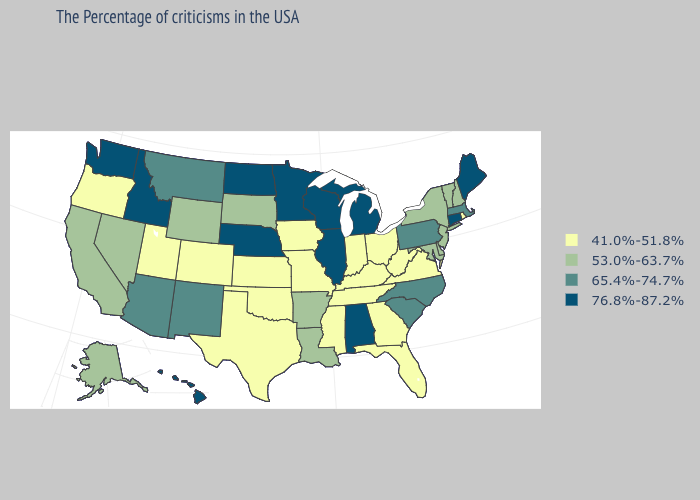What is the value of Nebraska?
Write a very short answer. 76.8%-87.2%. Name the states that have a value in the range 53.0%-63.7%?
Short answer required. New Hampshire, Vermont, New York, New Jersey, Delaware, Maryland, Louisiana, Arkansas, South Dakota, Wyoming, Nevada, California, Alaska. Does Mississippi have a lower value than Alaska?
Quick response, please. Yes. What is the value of Kentucky?
Answer briefly. 41.0%-51.8%. Which states hav the highest value in the Northeast?
Keep it brief. Maine, Connecticut. Name the states that have a value in the range 41.0%-51.8%?
Short answer required. Rhode Island, Virginia, West Virginia, Ohio, Florida, Georgia, Kentucky, Indiana, Tennessee, Mississippi, Missouri, Iowa, Kansas, Oklahoma, Texas, Colorado, Utah, Oregon. Name the states that have a value in the range 76.8%-87.2%?
Quick response, please. Maine, Connecticut, Michigan, Alabama, Wisconsin, Illinois, Minnesota, Nebraska, North Dakota, Idaho, Washington, Hawaii. What is the value of Alabama?
Concise answer only. 76.8%-87.2%. Among the states that border Colorado , which have the highest value?
Be succinct. Nebraska. Among the states that border New Jersey , does Delaware have the highest value?
Quick response, please. No. Which states have the lowest value in the USA?
Short answer required. Rhode Island, Virginia, West Virginia, Ohio, Florida, Georgia, Kentucky, Indiana, Tennessee, Mississippi, Missouri, Iowa, Kansas, Oklahoma, Texas, Colorado, Utah, Oregon. What is the value of Missouri?
Short answer required. 41.0%-51.8%. Does Connecticut have the highest value in the USA?
Be succinct. Yes. What is the highest value in the MidWest ?
Give a very brief answer. 76.8%-87.2%. Which states hav the highest value in the MidWest?
Give a very brief answer. Michigan, Wisconsin, Illinois, Minnesota, Nebraska, North Dakota. 